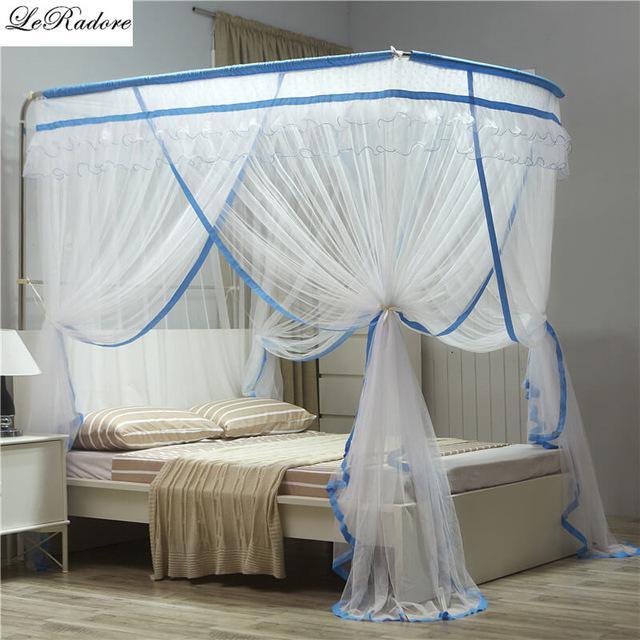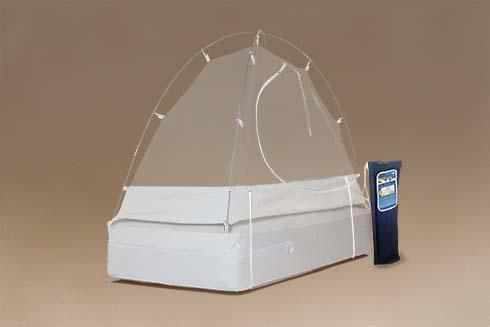The first image is the image on the left, the second image is the image on the right. Given the left and right images, does the statement "The left and right image contains the same number of tented canopies." hold true? Answer yes or no. No. The first image is the image on the left, the second image is the image on the right. Evaluate the accuracy of this statement regarding the images: "One image shows a dome canopy on top of a bed, and the other image features a sheer, blue trimmed canopy that ties like a curtain on at least one side of a bed.". Is it true? Answer yes or no. Yes. 